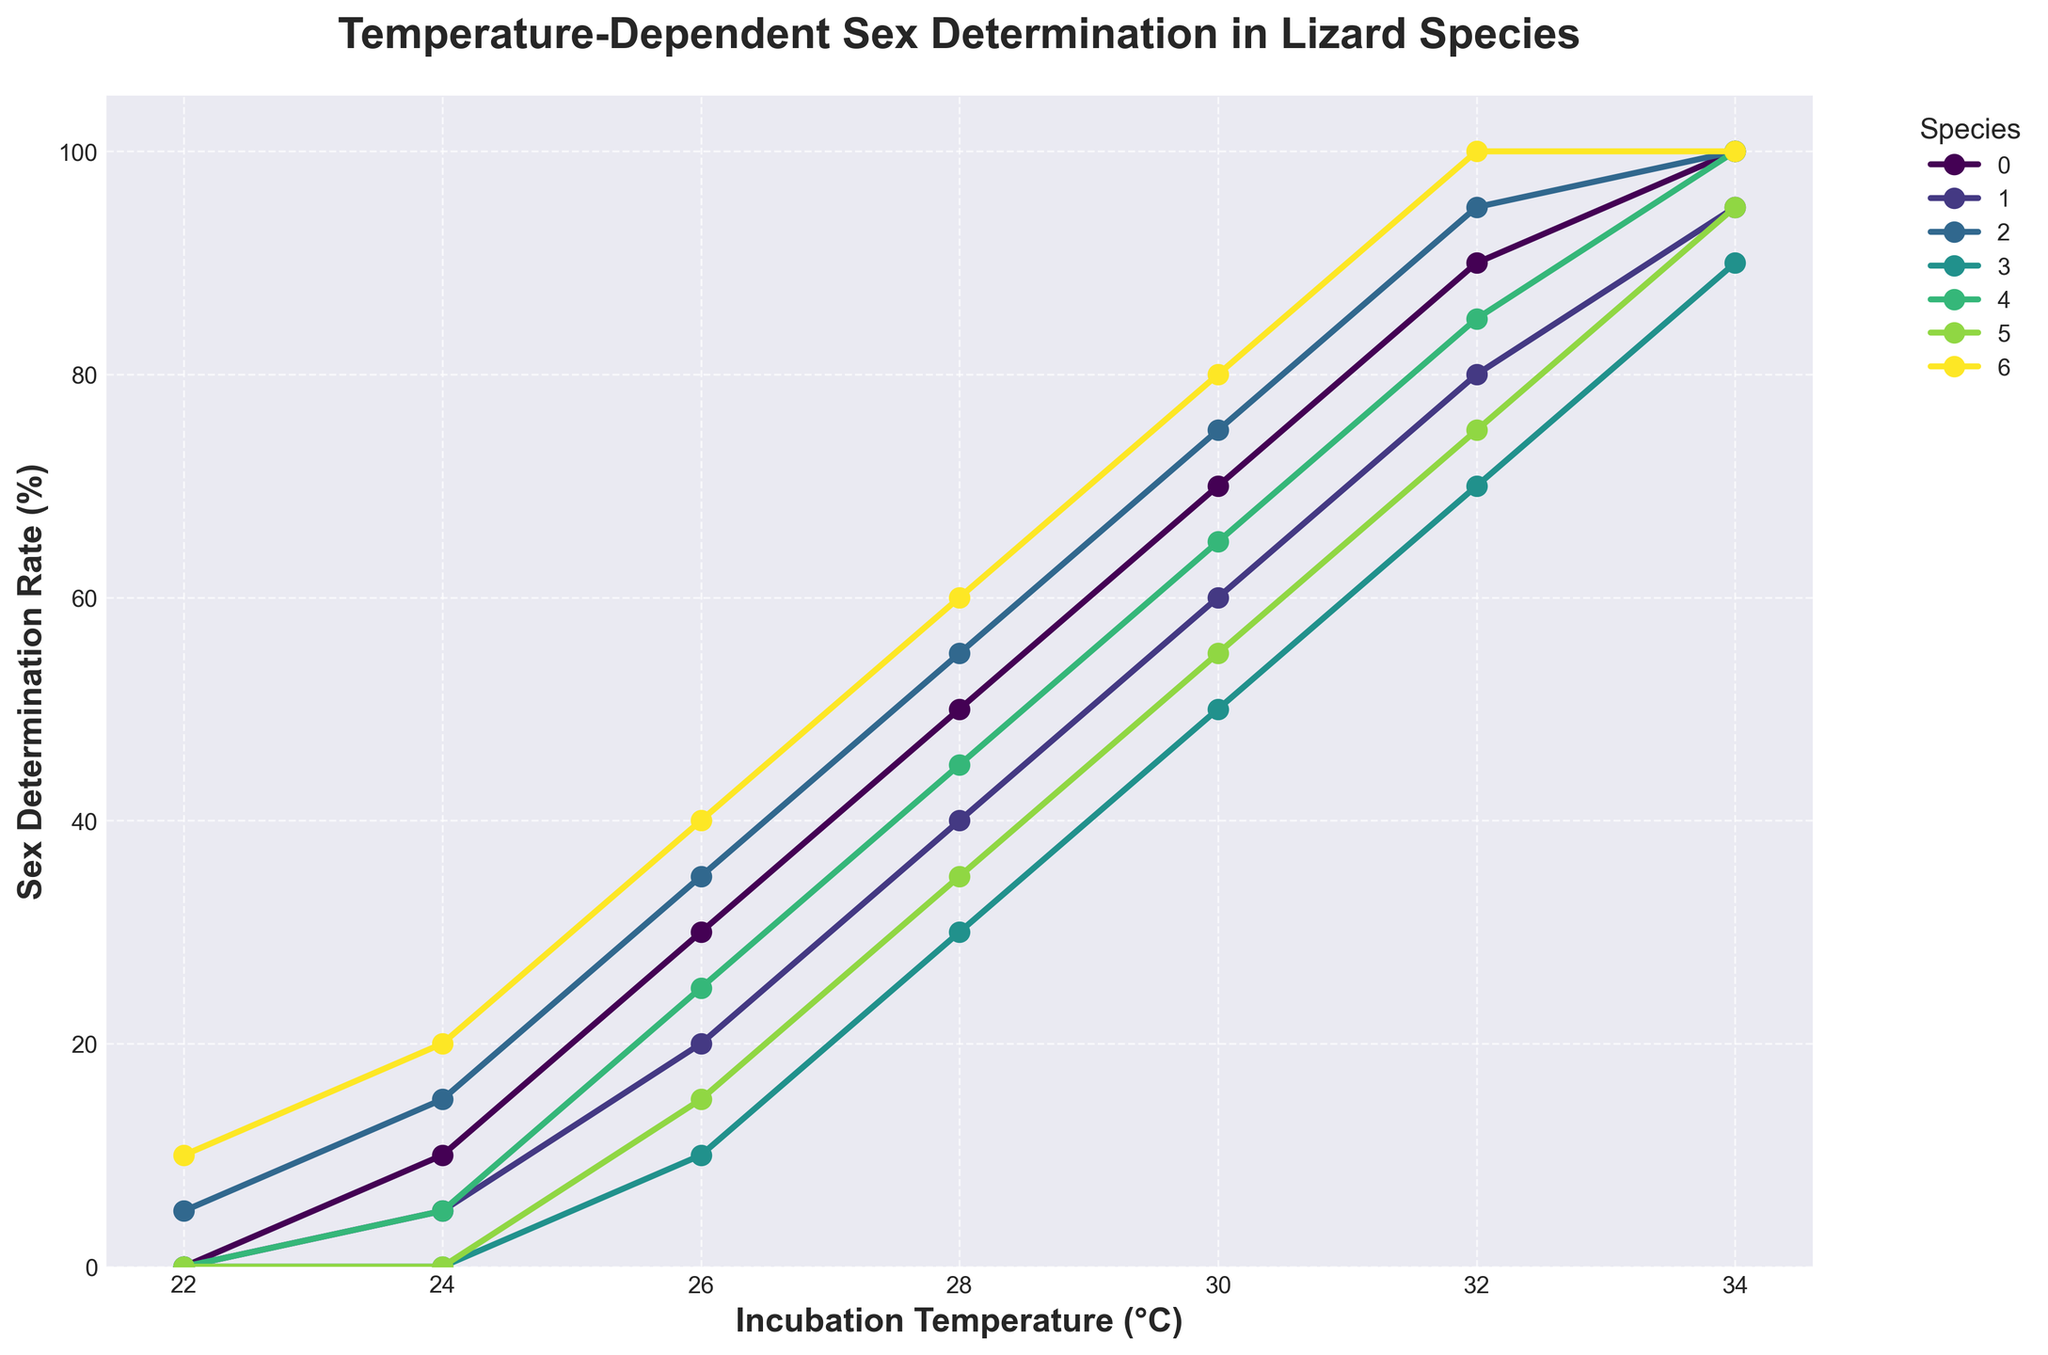Which lizard species has the highest sex determination rate at 32°C? By observing the data points at 32°C on the x-axis, we find that the Bearded Dragon, Komodo Dragon, and Leopard Gecko each have a rate of 100%, but Bearded Dragon, Komodo Dragon, and Leopard Gecko are all at 100%.
Answer: Bearded Dragon, Komodo Dragon, Leopard Gecko Which species has a lower sex determination rate at 22°C, Green Iguana or Komodo Dragon? At 22°C, the data points for Green Iguana and Komodo Dragon show a sex determination rate of 0% and 5%, respectively. Thus, Green Iguana has a lower rate.
Answer: Green Iguana What is the average sex determination rate for Green Iguana across all temperatures? Sum Green Iguana's sex determination rates at each temperature: 0, 5, 20, 40, 60, 80, 95. The total is 300. Divide by the number of temperatures (7): 300/7 ≈ 43.
Answer: 43 Is the sex determination rate for Central Bearded Dragon at 28°C higher than that of the Italian Wall Lizard at 34°C? Central Bearded Dragon's rate at 28°C is 45%, and the Italian Wall Lizard's rate at 34°C is 95%. 45% is not higher than 95%.
Answer: No At which temperature do Komodo Dragon and Leopard Gecko have the same sex determination rate? By comparing data points, Komodo Dragon and Leopard Gecko have the same sex determination rate of 100% at 34°C.
Answer: 34°C What is the difference in sex determination rate between Bearded Dragon and Eastern Fence Lizard at 30°C? Bearded Dragon has a rate of 70% and Eastern Fence Lizard has 50% at 30°C. The difference is 70 - 50 = 20%.
Answer: 20% Which species shows the steepest increase in sex determination rate between 24°C and 26°C? Calculate the differences in rates between 24°C and 26°C for each species: Bearded Dragon (10-0=10), Green Iguana (20-5=15), Komodo Dragon (35-15=20), Eastern Fence Lizard (10-0=10), Central Bearded Dragon (25-5=20), Italian Wall Lizard (15-0=15), Leopard Gecko (40-20=20). Komodo Dragon, Central Bearded Dragon, and Leopard Gecko show the steepest increases.
Answer: Komodo Dragon, Central Bearded Dragon, Leopard Gecko Does the sex determination rate for Leopard Gecko change between 32°C and 34°C? The data shows both 32°C and 34°C have a rate of 100% for Leopard Gecko, so there is no change.
Answer: No Is the sex determination rate for Eastern Fence Lizard at 24°C non-zero? At 24°C, the Eastern Fence Lizard's rate is 0%, indicating it is not non-zero.
Answer: No How much does the sex determination rate for Bearded Dragon change from 22°C to 34°C? Bearded Dragon's rate goes from 0% at 22°C to 100% at 34°C. The change is 100 - 0 = 100%.
Answer: 100% 